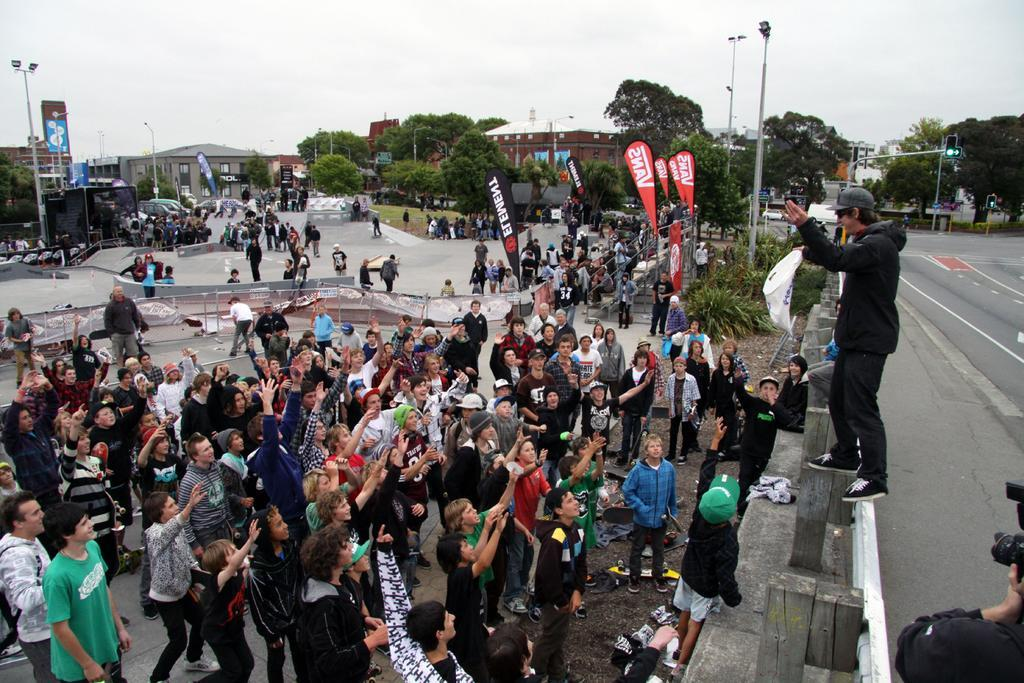Who or what can be seen in the image? There are people in the image. What type of natural elements are present in the image? There are trees in the image. What are the vertical structures in the image? There are poles in the image. What type of signage is present in the image? There are boards with text in the image. What type of man-made structures are visible in the image? There are buildings in the image. What is the surface on which people and vehicles are standing or moving? The ground is visible in the image. What part of the natural environment is visible in the image? The sky is visible in the image. What type of transportation can be seen in the image? There are vehicles in the image. What is the list of ingredients for the scale in the image? There is no scale present in the image, so there is no list of ingredients. What type of road can be seen in the image? There is no road visible in the image. 